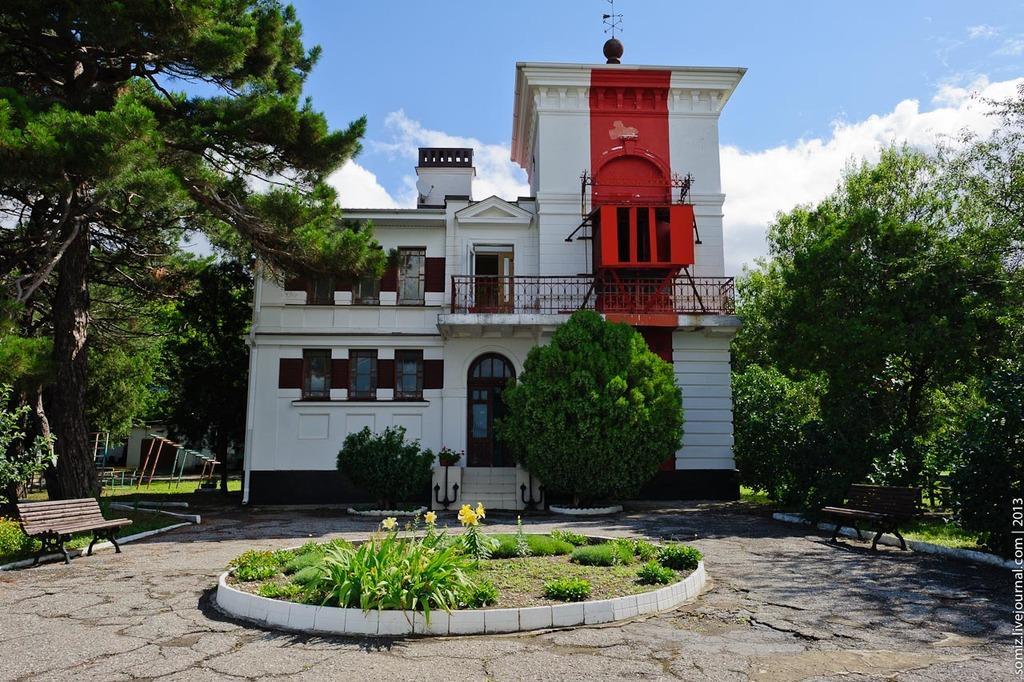In one or two sentences, can you explain what this image depicts? In the image we can see a building and these are the windows of the building. This is a fence, grass, bench, trees, water mark and a cloudy sky. 